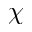<formula> <loc_0><loc_0><loc_500><loc_500>\chi</formula> 